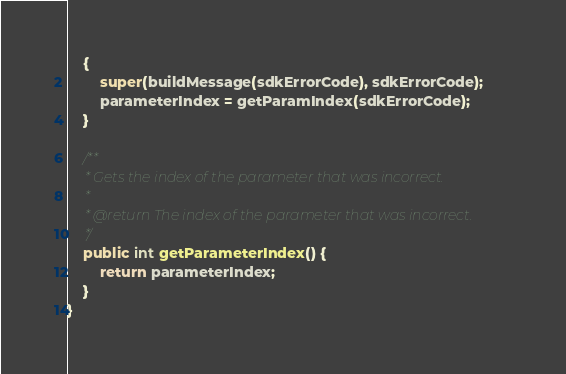Convert code to text. <code><loc_0><loc_0><loc_500><loc_500><_Java_>    {
		super(buildMessage(sdkErrorCode), sdkErrorCode);
		parameterIndex = getParamIndex(sdkErrorCode);
	}

	/**
	 * Gets the index of the parameter that was incorrect.
	 *
	 * @return The index of the parameter that was incorrect.
	 */
	public int getParameterIndex() {
		return parameterIndex;
	}
}
</code> 